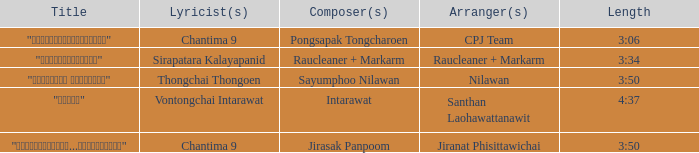Who was the arranger of "ขอโทษ"? Santhan Laohawattanawit. 